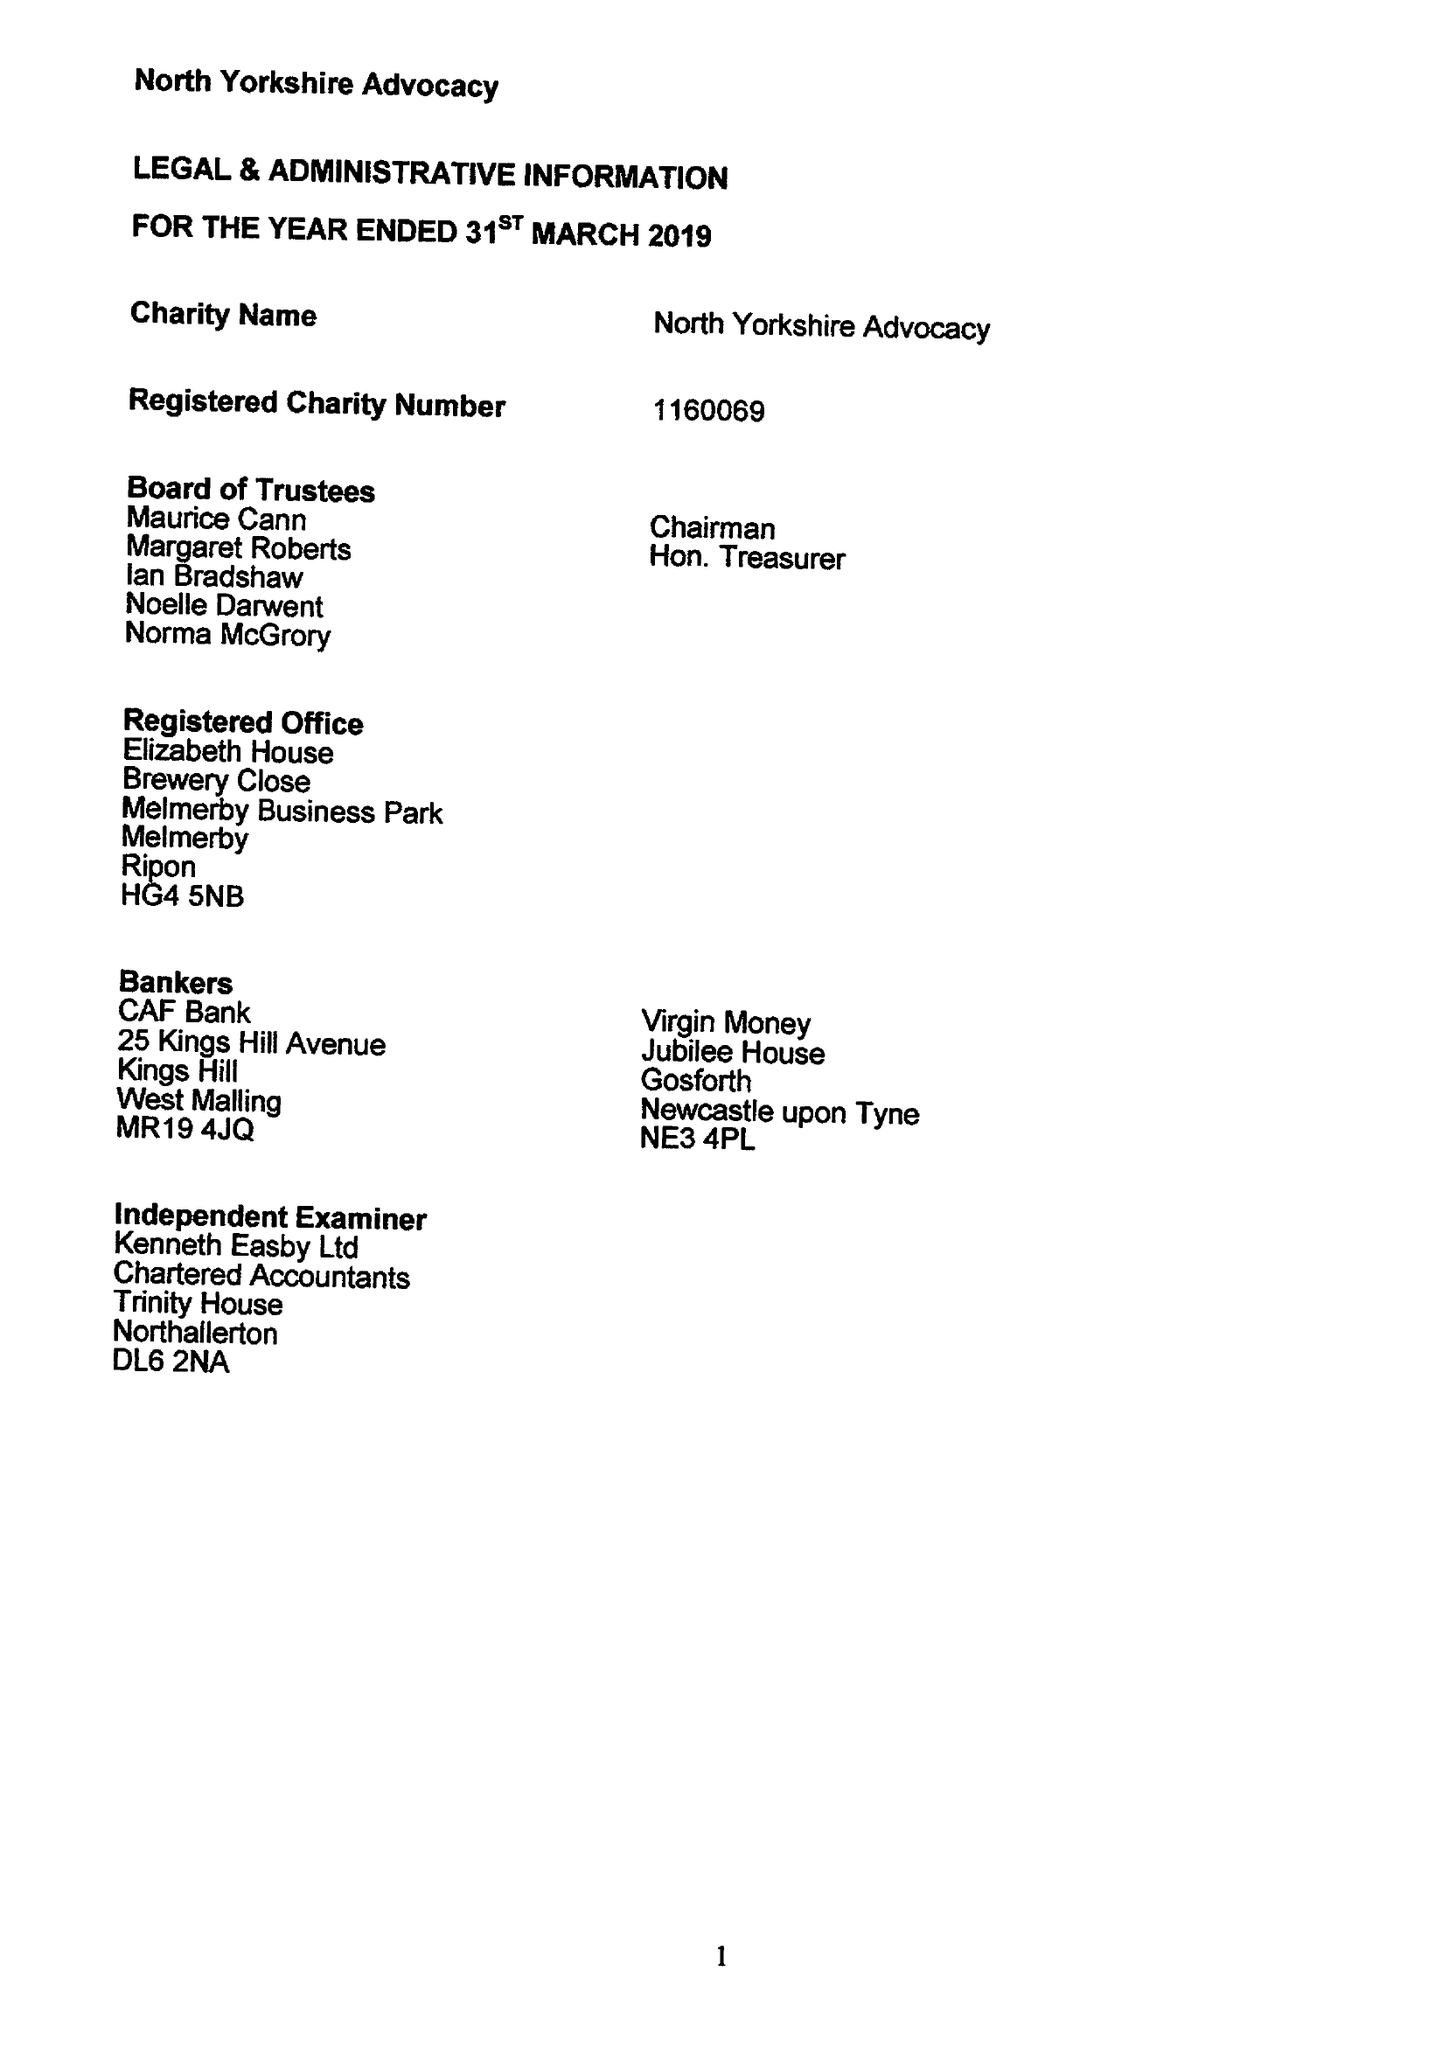What is the value for the charity_name?
Answer the question using a single word or phrase. North Yorkshire Advocacy 